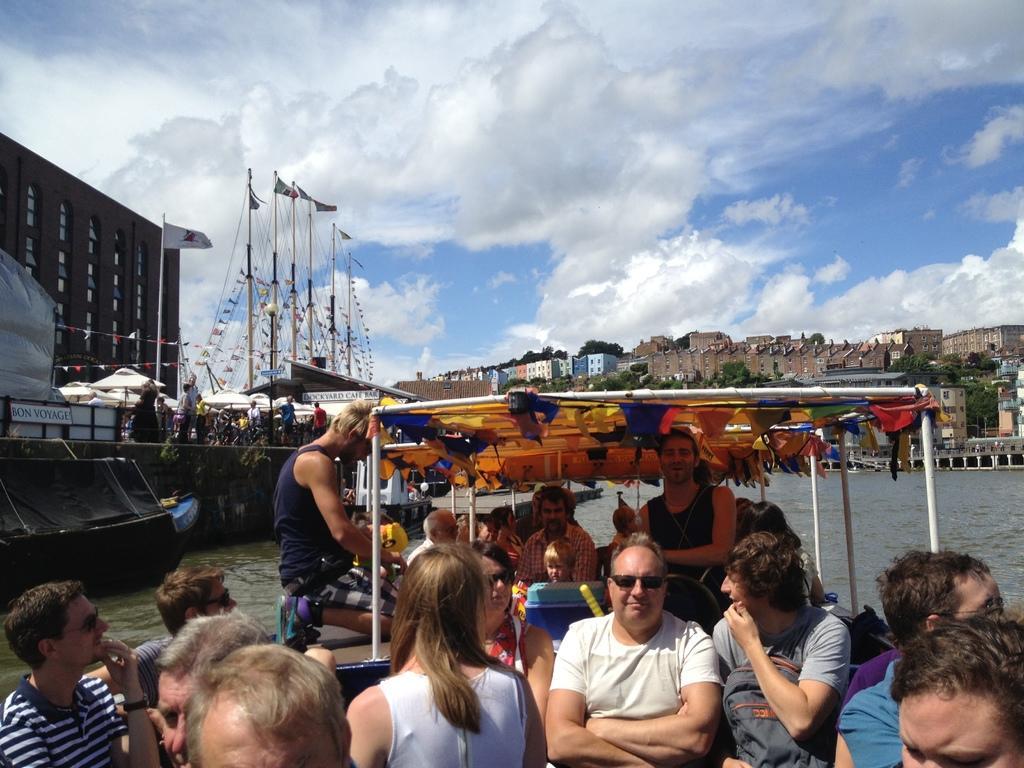Could you give a brief overview of what you see in this image? At the bottom of the image I can see few people are sitting in the boat. In the background, I can see the water and also buildings, trees. On the left side there are few boats and also some flags. At the top I can see the sky and clouds. 